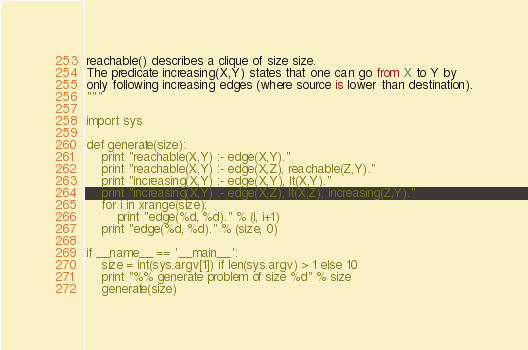Convert code to text. <code><loc_0><loc_0><loc_500><loc_500><_Python_>reachable() describes a clique of size size.
The predicate increasing(X,Y) states that one can go from X to Y by
only following increasing edges (where source is lower than destination).
"""

import sys

def generate(size):
    print "reachable(X,Y) :- edge(X,Y)."
    print "reachable(X,Y) :- edge(X,Z), reachable(Z,Y)."
    print "increasing(X,Y) :- edge(X,Y), lt(X,Y)."
    print "increasing(X,Y) :- edge(X,Z), lt(X,Z), increasing(Z,Y)."
    for i in xrange(size):
        print "edge(%d, %d)." % (i, i+1)
    print "edge(%d, %d)." % (size, 0)

if __name__ == '__main__':
    size = int(sys.argv[1]) if len(sys.argv) > 1 else 10
    print "%% generate problem of size %d" % size
    generate(size)
</code> 